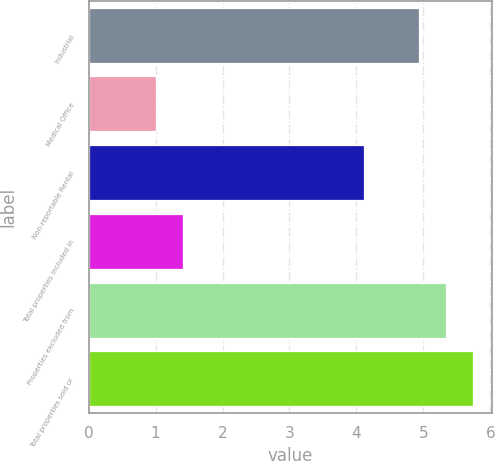<chart> <loc_0><loc_0><loc_500><loc_500><bar_chart><fcel>Industrial<fcel>Medical Office<fcel>Non-reportable Rental<fcel>Total properties included in<fcel>Properties excluded from<fcel>Total properties sold or<nl><fcel>4.94<fcel>1.01<fcel>4.11<fcel>1.41<fcel>5.34<fcel>5.74<nl></chart> 